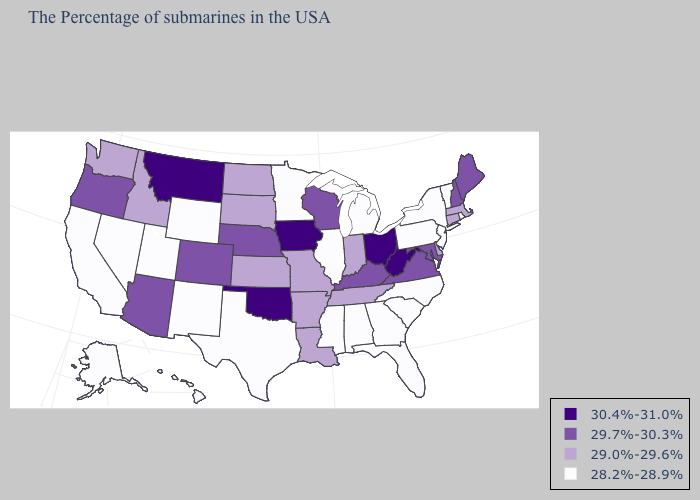What is the highest value in the USA?
Quick response, please. 30.4%-31.0%. What is the value of Kansas?
Answer briefly. 29.0%-29.6%. Which states hav the highest value in the West?
Be succinct. Montana. Does Michigan have a lower value than Tennessee?
Be succinct. Yes. Does Michigan have the lowest value in the USA?
Quick response, please. Yes. Among the states that border South Dakota , which have the highest value?
Concise answer only. Iowa, Montana. Name the states that have a value in the range 29.0%-29.6%?
Quick response, please. Massachusetts, Connecticut, Delaware, Indiana, Tennessee, Louisiana, Missouri, Arkansas, Kansas, South Dakota, North Dakota, Idaho, Washington. Does Ohio have the lowest value in the MidWest?
Short answer required. No. Does Massachusetts have the same value as South Carolina?
Concise answer only. No. Does the first symbol in the legend represent the smallest category?
Keep it brief. No. Among the states that border Massachusetts , which have the lowest value?
Answer briefly. Rhode Island, Vermont, New York. Among the states that border Indiana , which have the lowest value?
Write a very short answer. Michigan, Illinois. Name the states that have a value in the range 29.7%-30.3%?
Concise answer only. Maine, New Hampshire, Maryland, Virginia, Kentucky, Wisconsin, Nebraska, Colorado, Arizona, Oregon. Does New Jersey have the same value as Montana?
Be succinct. No. 